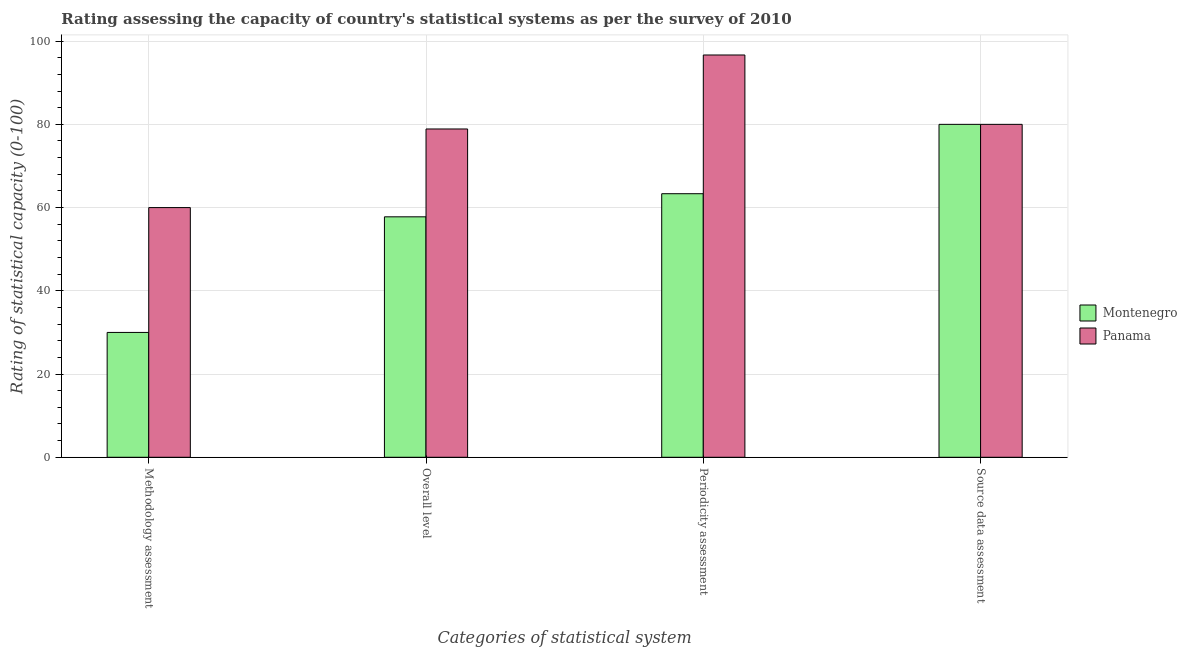How many different coloured bars are there?
Keep it short and to the point. 2. Are the number of bars on each tick of the X-axis equal?
Your answer should be compact. Yes. How many bars are there on the 4th tick from the right?
Your answer should be very brief. 2. What is the label of the 4th group of bars from the left?
Make the answer very short. Source data assessment. What is the periodicity assessment rating in Panama?
Offer a very short reply. 96.67. Across all countries, what is the maximum overall level rating?
Offer a very short reply. 78.89. Across all countries, what is the minimum periodicity assessment rating?
Make the answer very short. 63.33. In which country was the methodology assessment rating maximum?
Offer a terse response. Panama. In which country was the overall level rating minimum?
Keep it short and to the point. Montenegro. What is the difference between the source data assessment rating in Panama and the overall level rating in Montenegro?
Provide a short and direct response. 22.22. What is the average source data assessment rating per country?
Make the answer very short. 80. What is the difference between the source data assessment rating and methodology assessment rating in Montenegro?
Offer a very short reply. 50. In how many countries, is the overall level rating greater than 88 ?
Provide a succinct answer. 0. What is the difference between the highest and the lowest overall level rating?
Provide a succinct answer. 21.11. Is it the case that in every country, the sum of the periodicity assessment rating and methodology assessment rating is greater than the sum of source data assessment rating and overall level rating?
Your answer should be compact. No. What does the 2nd bar from the left in Source data assessment represents?
Ensure brevity in your answer.  Panama. What does the 2nd bar from the right in Periodicity assessment represents?
Your answer should be compact. Montenegro. How many bars are there?
Provide a succinct answer. 8. Are all the bars in the graph horizontal?
Your answer should be compact. No. Are the values on the major ticks of Y-axis written in scientific E-notation?
Provide a short and direct response. No. Does the graph contain grids?
Your answer should be very brief. Yes. What is the title of the graph?
Your response must be concise. Rating assessing the capacity of country's statistical systems as per the survey of 2010 . Does "Cyprus" appear as one of the legend labels in the graph?
Your response must be concise. No. What is the label or title of the X-axis?
Your response must be concise. Categories of statistical system. What is the label or title of the Y-axis?
Make the answer very short. Rating of statistical capacity (0-100). What is the Rating of statistical capacity (0-100) in Montenegro in Methodology assessment?
Offer a terse response. 30. What is the Rating of statistical capacity (0-100) of Montenegro in Overall level?
Provide a succinct answer. 57.78. What is the Rating of statistical capacity (0-100) of Panama in Overall level?
Provide a succinct answer. 78.89. What is the Rating of statistical capacity (0-100) in Montenegro in Periodicity assessment?
Your response must be concise. 63.33. What is the Rating of statistical capacity (0-100) of Panama in Periodicity assessment?
Offer a very short reply. 96.67. What is the Rating of statistical capacity (0-100) in Montenegro in Source data assessment?
Provide a succinct answer. 80. What is the Rating of statistical capacity (0-100) in Panama in Source data assessment?
Your answer should be very brief. 80. Across all Categories of statistical system, what is the maximum Rating of statistical capacity (0-100) in Panama?
Make the answer very short. 96.67. Across all Categories of statistical system, what is the minimum Rating of statistical capacity (0-100) in Montenegro?
Provide a short and direct response. 30. Across all Categories of statistical system, what is the minimum Rating of statistical capacity (0-100) of Panama?
Make the answer very short. 60. What is the total Rating of statistical capacity (0-100) of Montenegro in the graph?
Give a very brief answer. 231.11. What is the total Rating of statistical capacity (0-100) of Panama in the graph?
Make the answer very short. 315.56. What is the difference between the Rating of statistical capacity (0-100) in Montenegro in Methodology assessment and that in Overall level?
Provide a succinct answer. -27.78. What is the difference between the Rating of statistical capacity (0-100) in Panama in Methodology assessment and that in Overall level?
Give a very brief answer. -18.89. What is the difference between the Rating of statistical capacity (0-100) of Montenegro in Methodology assessment and that in Periodicity assessment?
Make the answer very short. -33.33. What is the difference between the Rating of statistical capacity (0-100) in Panama in Methodology assessment and that in Periodicity assessment?
Provide a succinct answer. -36.67. What is the difference between the Rating of statistical capacity (0-100) of Montenegro in Overall level and that in Periodicity assessment?
Offer a terse response. -5.56. What is the difference between the Rating of statistical capacity (0-100) in Panama in Overall level and that in Periodicity assessment?
Make the answer very short. -17.78. What is the difference between the Rating of statistical capacity (0-100) in Montenegro in Overall level and that in Source data assessment?
Give a very brief answer. -22.22. What is the difference between the Rating of statistical capacity (0-100) of Panama in Overall level and that in Source data assessment?
Your answer should be very brief. -1.11. What is the difference between the Rating of statistical capacity (0-100) in Montenegro in Periodicity assessment and that in Source data assessment?
Offer a terse response. -16.67. What is the difference between the Rating of statistical capacity (0-100) of Panama in Periodicity assessment and that in Source data assessment?
Your answer should be very brief. 16.67. What is the difference between the Rating of statistical capacity (0-100) in Montenegro in Methodology assessment and the Rating of statistical capacity (0-100) in Panama in Overall level?
Give a very brief answer. -48.89. What is the difference between the Rating of statistical capacity (0-100) in Montenegro in Methodology assessment and the Rating of statistical capacity (0-100) in Panama in Periodicity assessment?
Your answer should be compact. -66.67. What is the difference between the Rating of statistical capacity (0-100) of Montenegro in Overall level and the Rating of statistical capacity (0-100) of Panama in Periodicity assessment?
Your answer should be very brief. -38.89. What is the difference between the Rating of statistical capacity (0-100) of Montenegro in Overall level and the Rating of statistical capacity (0-100) of Panama in Source data assessment?
Make the answer very short. -22.22. What is the difference between the Rating of statistical capacity (0-100) of Montenegro in Periodicity assessment and the Rating of statistical capacity (0-100) of Panama in Source data assessment?
Your answer should be very brief. -16.67. What is the average Rating of statistical capacity (0-100) in Montenegro per Categories of statistical system?
Give a very brief answer. 57.78. What is the average Rating of statistical capacity (0-100) of Panama per Categories of statistical system?
Your answer should be very brief. 78.89. What is the difference between the Rating of statistical capacity (0-100) in Montenegro and Rating of statistical capacity (0-100) in Panama in Overall level?
Your answer should be compact. -21.11. What is the difference between the Rating of statistical capacity (0-100) in Montenegro and Rating of statistical capacity (0-100) in Panama in Periodicity assessment?
Your answer should be compact. -33.33. What is the difference between the Rating of statistical capacity (0-100) of Montenegro and Rating of statistical capacity (0-100) of Panama in Source data assessment?
Make the answer very short. 0. What is the ratio of the Rating of statistical capacity (0-100) in Montenegro in Methodology assessment to that in Overall level?
Your answer should be compact. 0.52. What is the ratio of the Rating of statistical capacity (0-100) of Panama in Methodology assessment to that in Overall level?
Your answer should be compact. 0.76. What is the ratio of the Rating of statistical capacity (0-100) of Montenegro in Methodology assessment to that in Periodicity assessment?
Give a very brief answer. 0.47. What is the ratio of the Rating of statistical capacity (0-100) in Panama in Methodology assessment to that in Periodicity assessment?
Offer a terse response. 0.62. What is the ratio of the Rating of statistical capacity (0-100) of Panama in Methodology assessment to that in Source data assessment?
Your response must be concise. 0.75. What is the ratio of the Rating of statistical capacity (0-100) in Montenegro in Overall level to that in Periodicity assessment?
Give a very brief answer. 0.91. What is the ratio of the Rating of statistical capacity (0-100) in Panama in Overall level to that in Periodicity assessment?
Make the answer very short. 0.82. What is the ratio of the Rating of statistical capacity (0-100) in Montenegro in Overall level to that in Source data assessment?
Give a very brief answer. 0.72. What is the ratio of the Rating of statistical capacity (0-100) in Panama in Overall level to that in Source data assessment?
Provide a succinct answer. 0.99. What is the ratio of the Rating of statistical capacity (0-100) in Montenegro in Periodicity assessment to that in Source data assessment?
Keep it short and to the point. 0.79. What is the ratio of the Rating of statistical capacity (0-100) of Panama in Periodicity assessment to that in Source data assessment?
Make the answer very short. 1.21. What is the difference between the highest and the second highest Rating of statistical capacity (0-100) of Montenegro?
Ensure brevity in your answer.  16.67. What is the difference between the highest and the second highest Rating of statistical capacity (0-100) of Panama?
Ensure brevity in your answer.  16.67. What is the difference between the highest and the lowest Rating of statistical capacity (0-100) in Montenegro?
Ensure brevity in your answer.  50. What is the difference between the highest and the lowest Rating of statistical capacity (0-100) of Panama?
Provide a short and direct response. 36.67. 